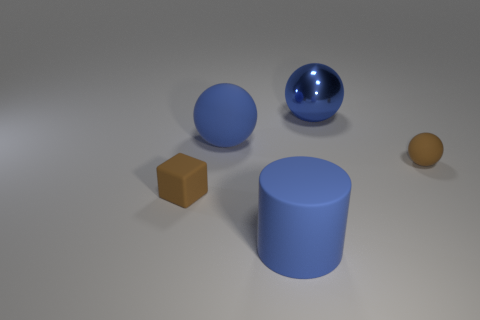Add 1 rubber cylinders. How many objects exist? 6 Subtract all balls. How many objects are left? 2 Add 2 small rubber objects. How many small rubber objects are left? 4 Add 5 big blue objects. How many big blue objects exist? 8 Subtract 0 yellow cubes. How many objects are left? 5 Subtract all big blue rubber balls. Subtract all tiny brown rubber spheres. How many objects are left? 3 